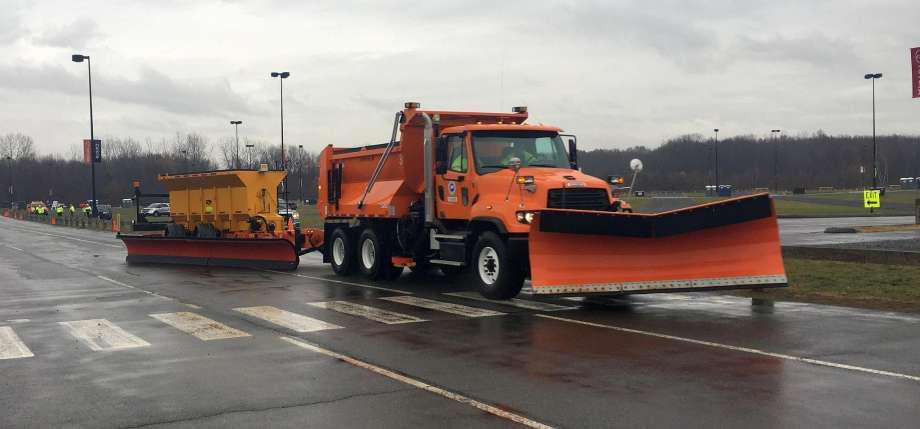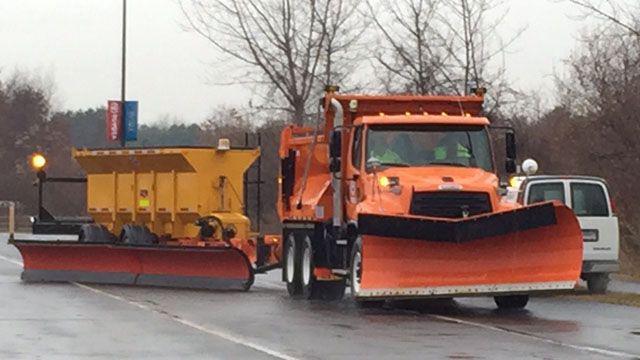The first image is the image on the left, the second image is the image on the right. Given the left and right images, does the statement "Left image shows one orange truck in front of a yellower piece of equipment." hold true? Answer yes or no. Yes. The first image is the image on the left, the second image is the image on the right. Examine the images to the left and right. Is the description "There is one white vehicle." accurate? Answer yes or no. Yes. 